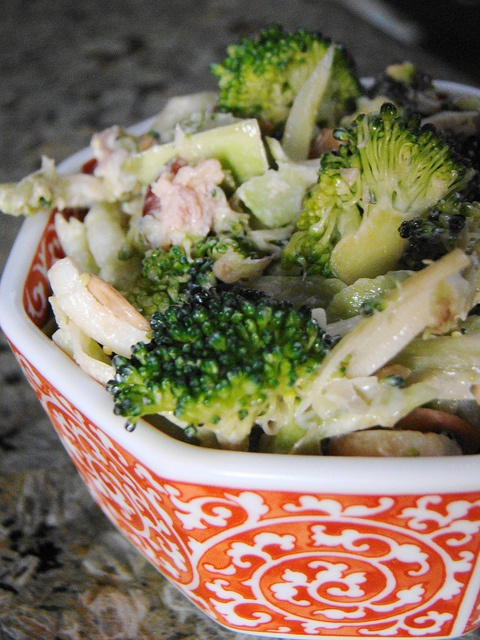Describe the objects in this image and their specific colors. I can see bowl in black, lightgray, olive, and darkgray tones, broccoli in black, darkgreen, and olive tones, broccoli in black and olive tones, broccoli in black, darkgreen, and olive tones, and broccoli in black, darkgreen, gray, and tan tones in this image. 